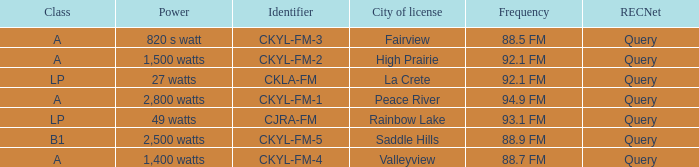What is the City of license with a 88.7 fm frequency Valleyview. 